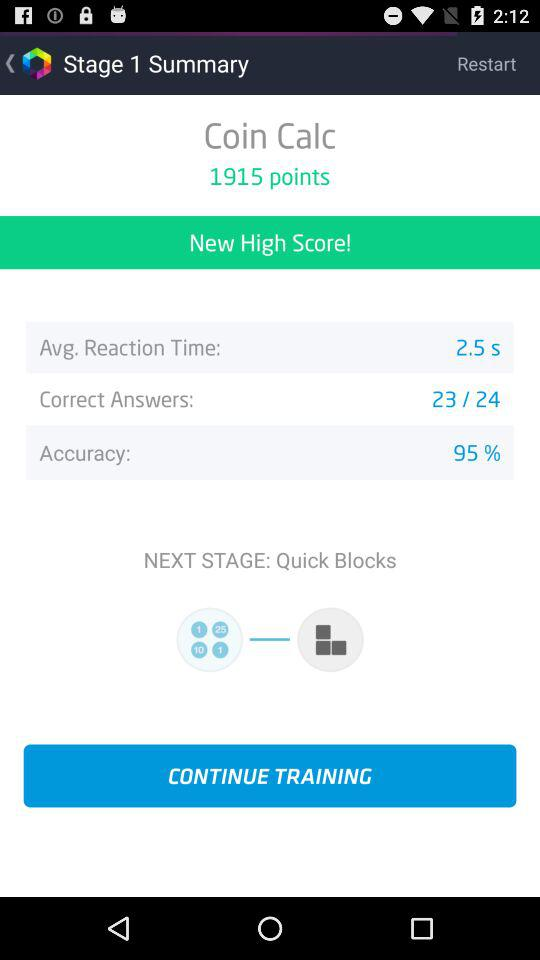What is the average reaction time? The average reaction time is 2.5 seconds. 